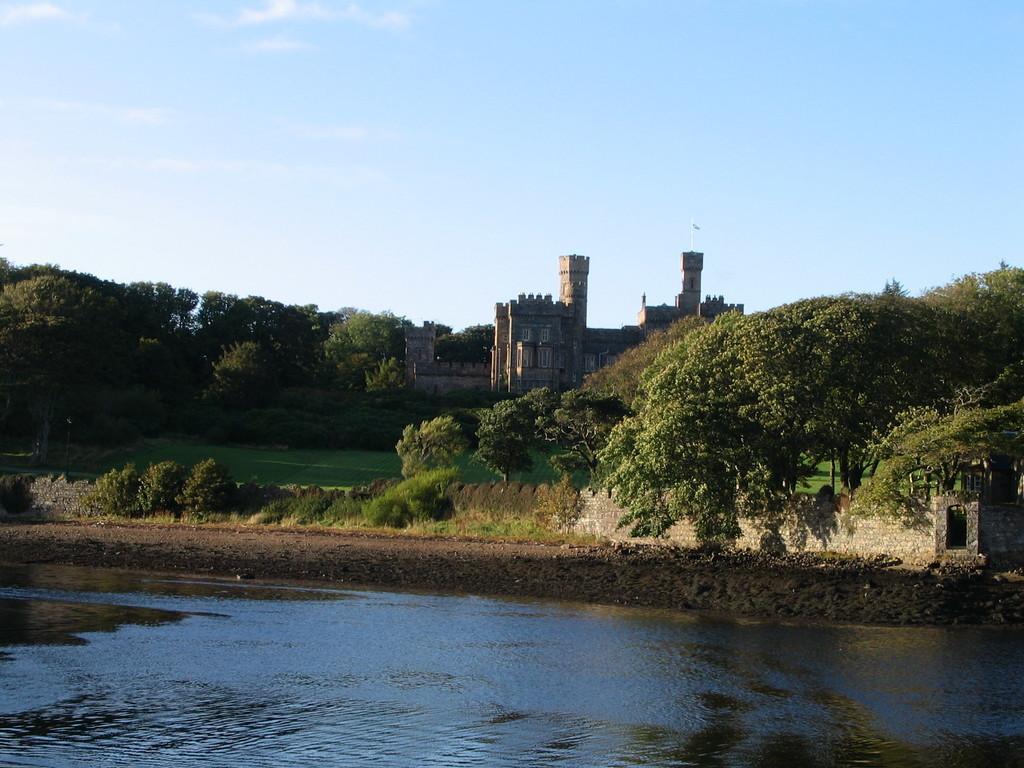Please provide a concise description of this image. In this picture I can see the monument, beside that I can see many trees, plants and grass. At the bottom I can see the lake. At the top I can see the sky and clouds. At the top of the monument there is a flag. 